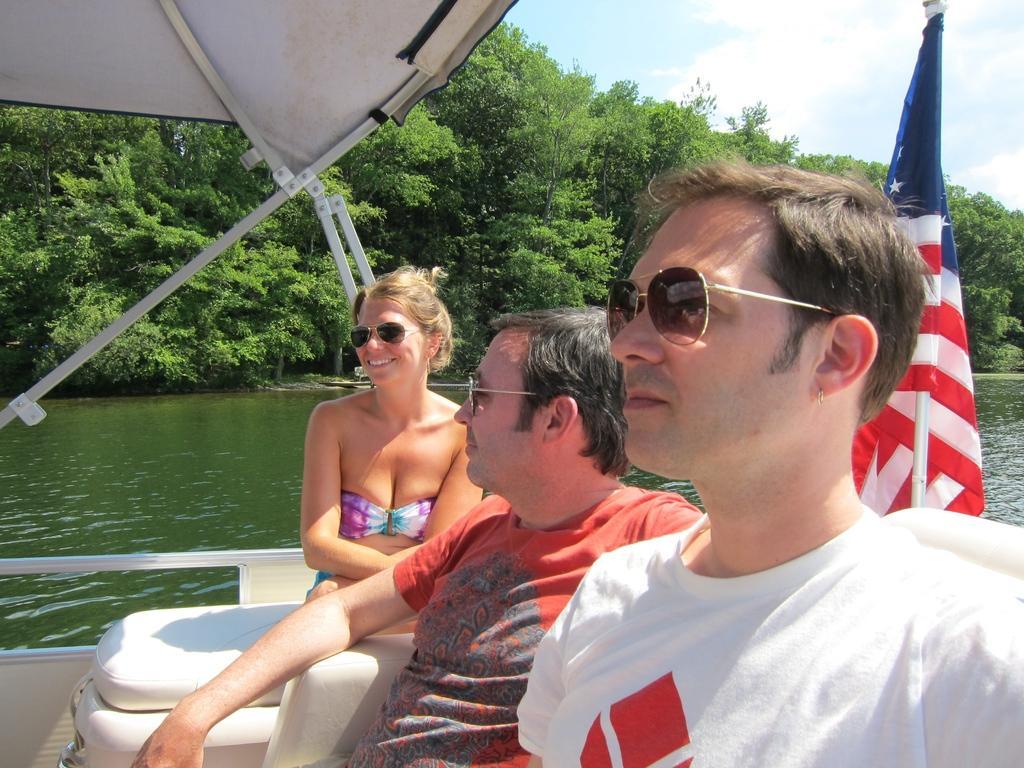Please provide a concise description of this image. In this picture we can see three people sitting on a boat. There is a flag on this boat. We can see a few trees in the background. Sky is blue in color and cloudy. 